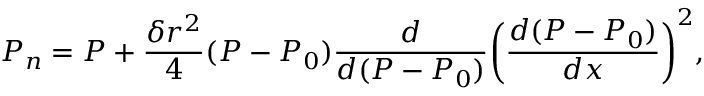Convert formula to latex. <formula><loc_0><loc_0><loc_500><loc_500>P _ { n } = P + \frac { \delta r ^ { 2 } } { 4 } ( P - P _ { 0 } ) \frac { d } { d ( P - P _ { 0 } ) } { \left ( \frac { d ( P - P _ { 0 } ) } { d x } \right ) } ^ { 2 } ,</formula> 